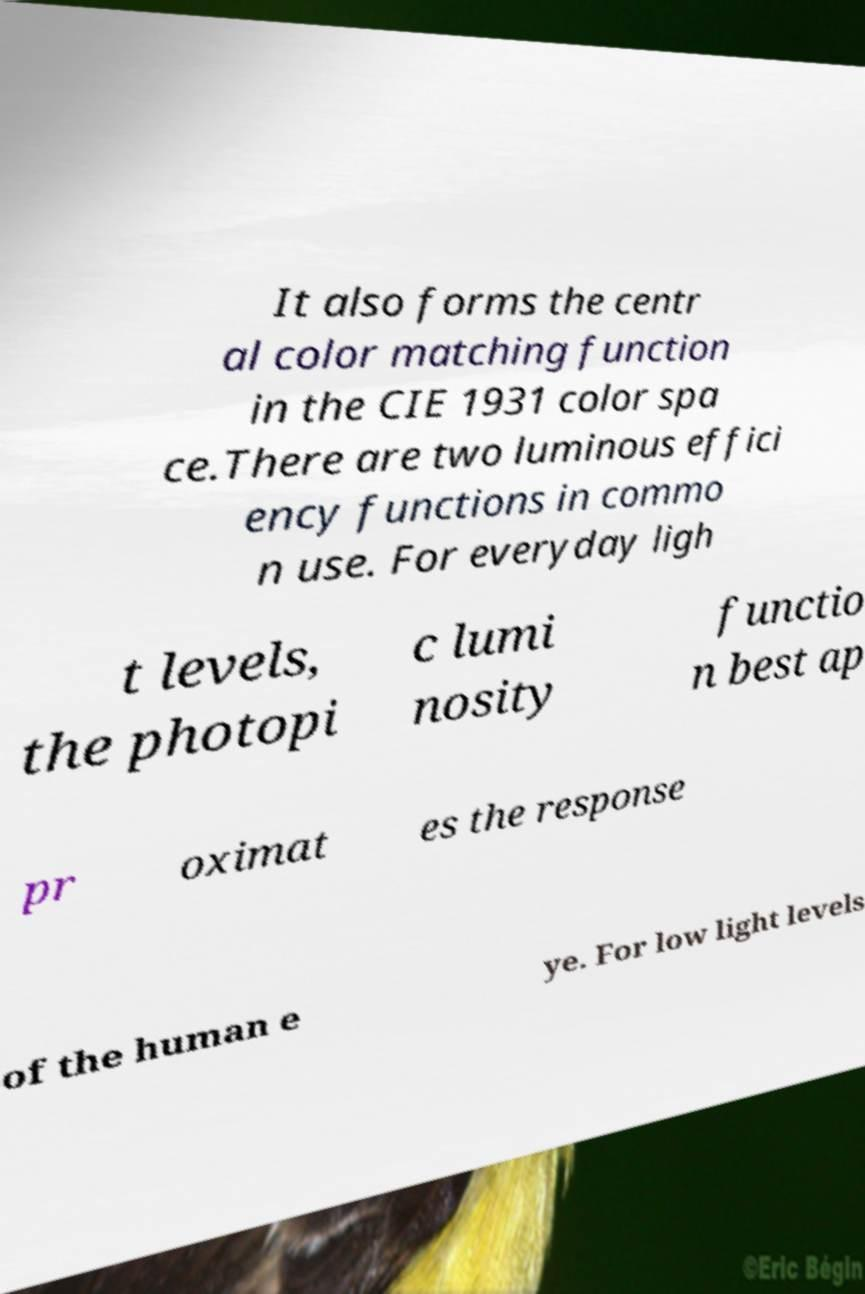Can you read and provide the text displayed in the image?This photo seems to have some interesting text. Can you extract and type it out for me? It also forms the centr al color matching function in the CIE 1931 color spa ce.There are two luminous effici ency functions in commo n use. For everyday ligh t levels, the photopi c lumi nosity functio n best ap pr oximat es the response of the human e ye. For low light levels 